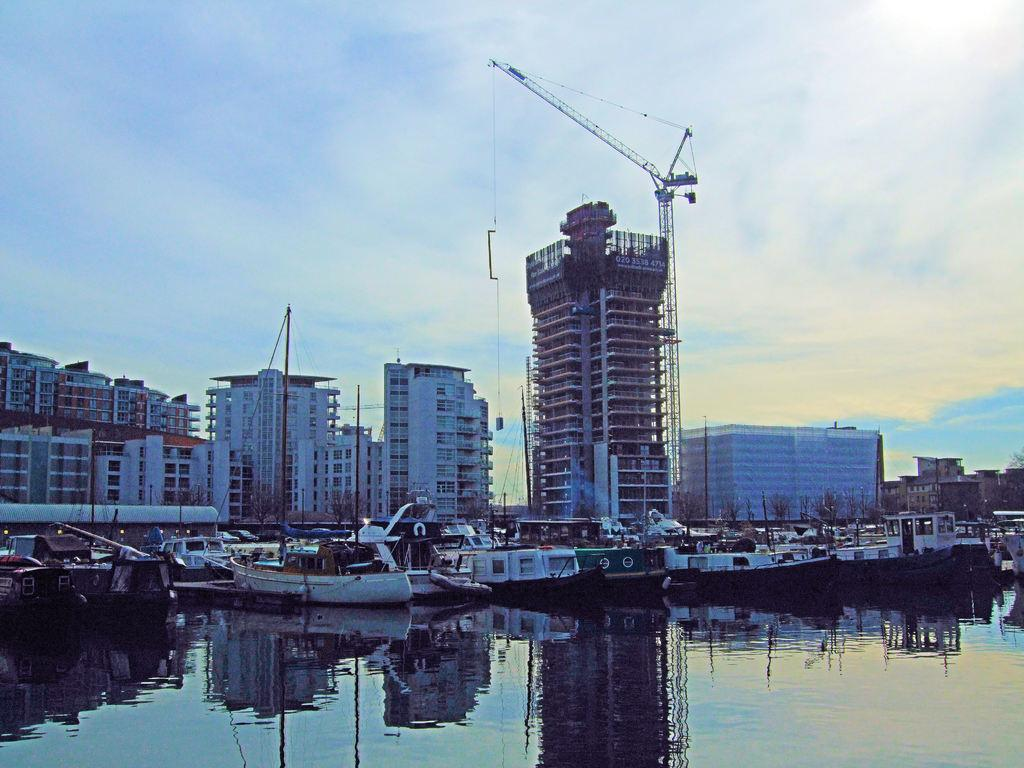What is in the front of the image? There is water in the front of the image. What can be seen in the background of the image? There are boats, buildings, and trees in the background of the image. What is the condition of the sky in the image? The sky is cloudy in the image. What direction is the steel beam pointing in the image? There is no steel beam present in the image. What form does the water take in the image? The water in the image appears to be in a natural, flowing form, such as a river or lake. 